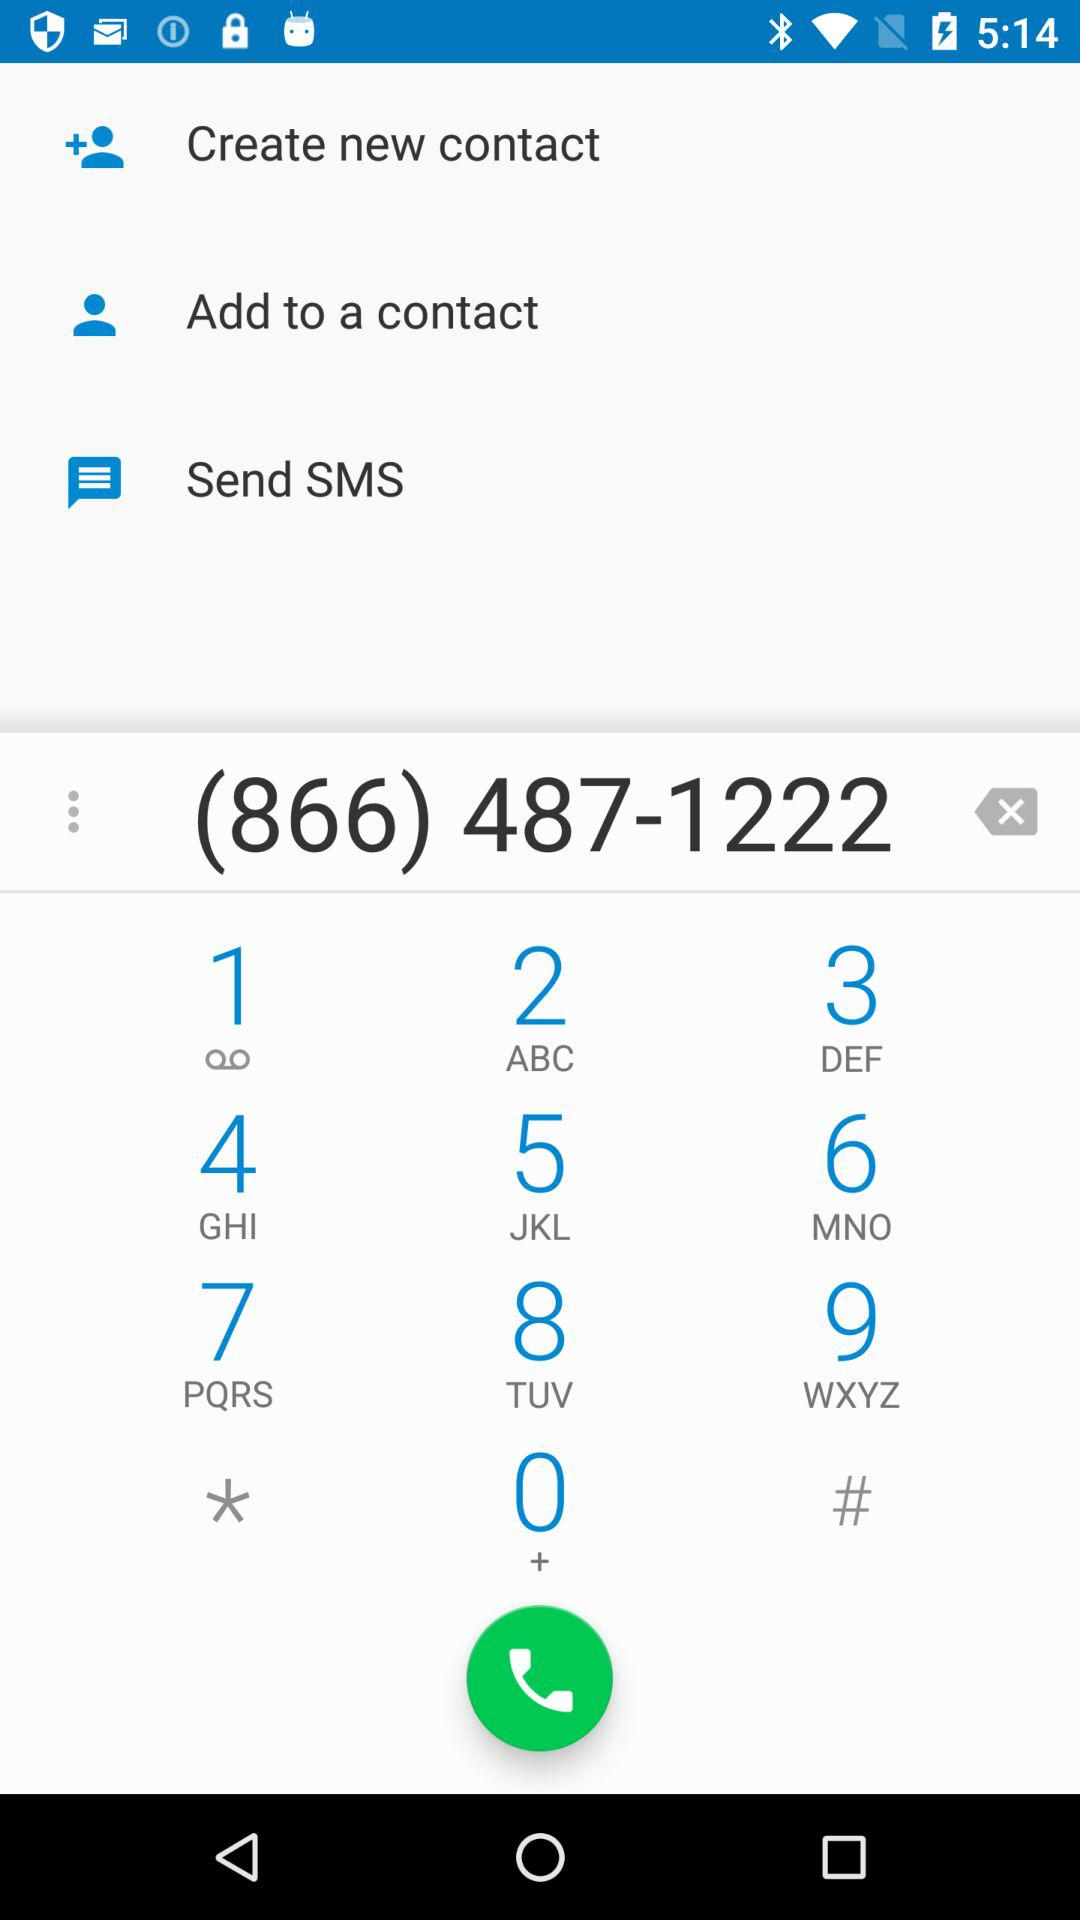What number has been dialed? The dialed number is (866) 487-1222. 